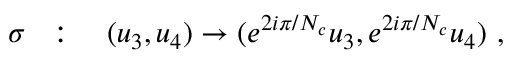Convert formula to latex. <formula><loc_0><loc_0><loc_500><loc_500>\sigma \colon \quad ( u _ { 3 } , u _ { 4 } ) \to ( e ^ { 2 i \pi / N _ { c } } u _ { 3 } , e ^ { 2 i \pi / N _ { c } } u _ { 4 } ) ,</formula> 